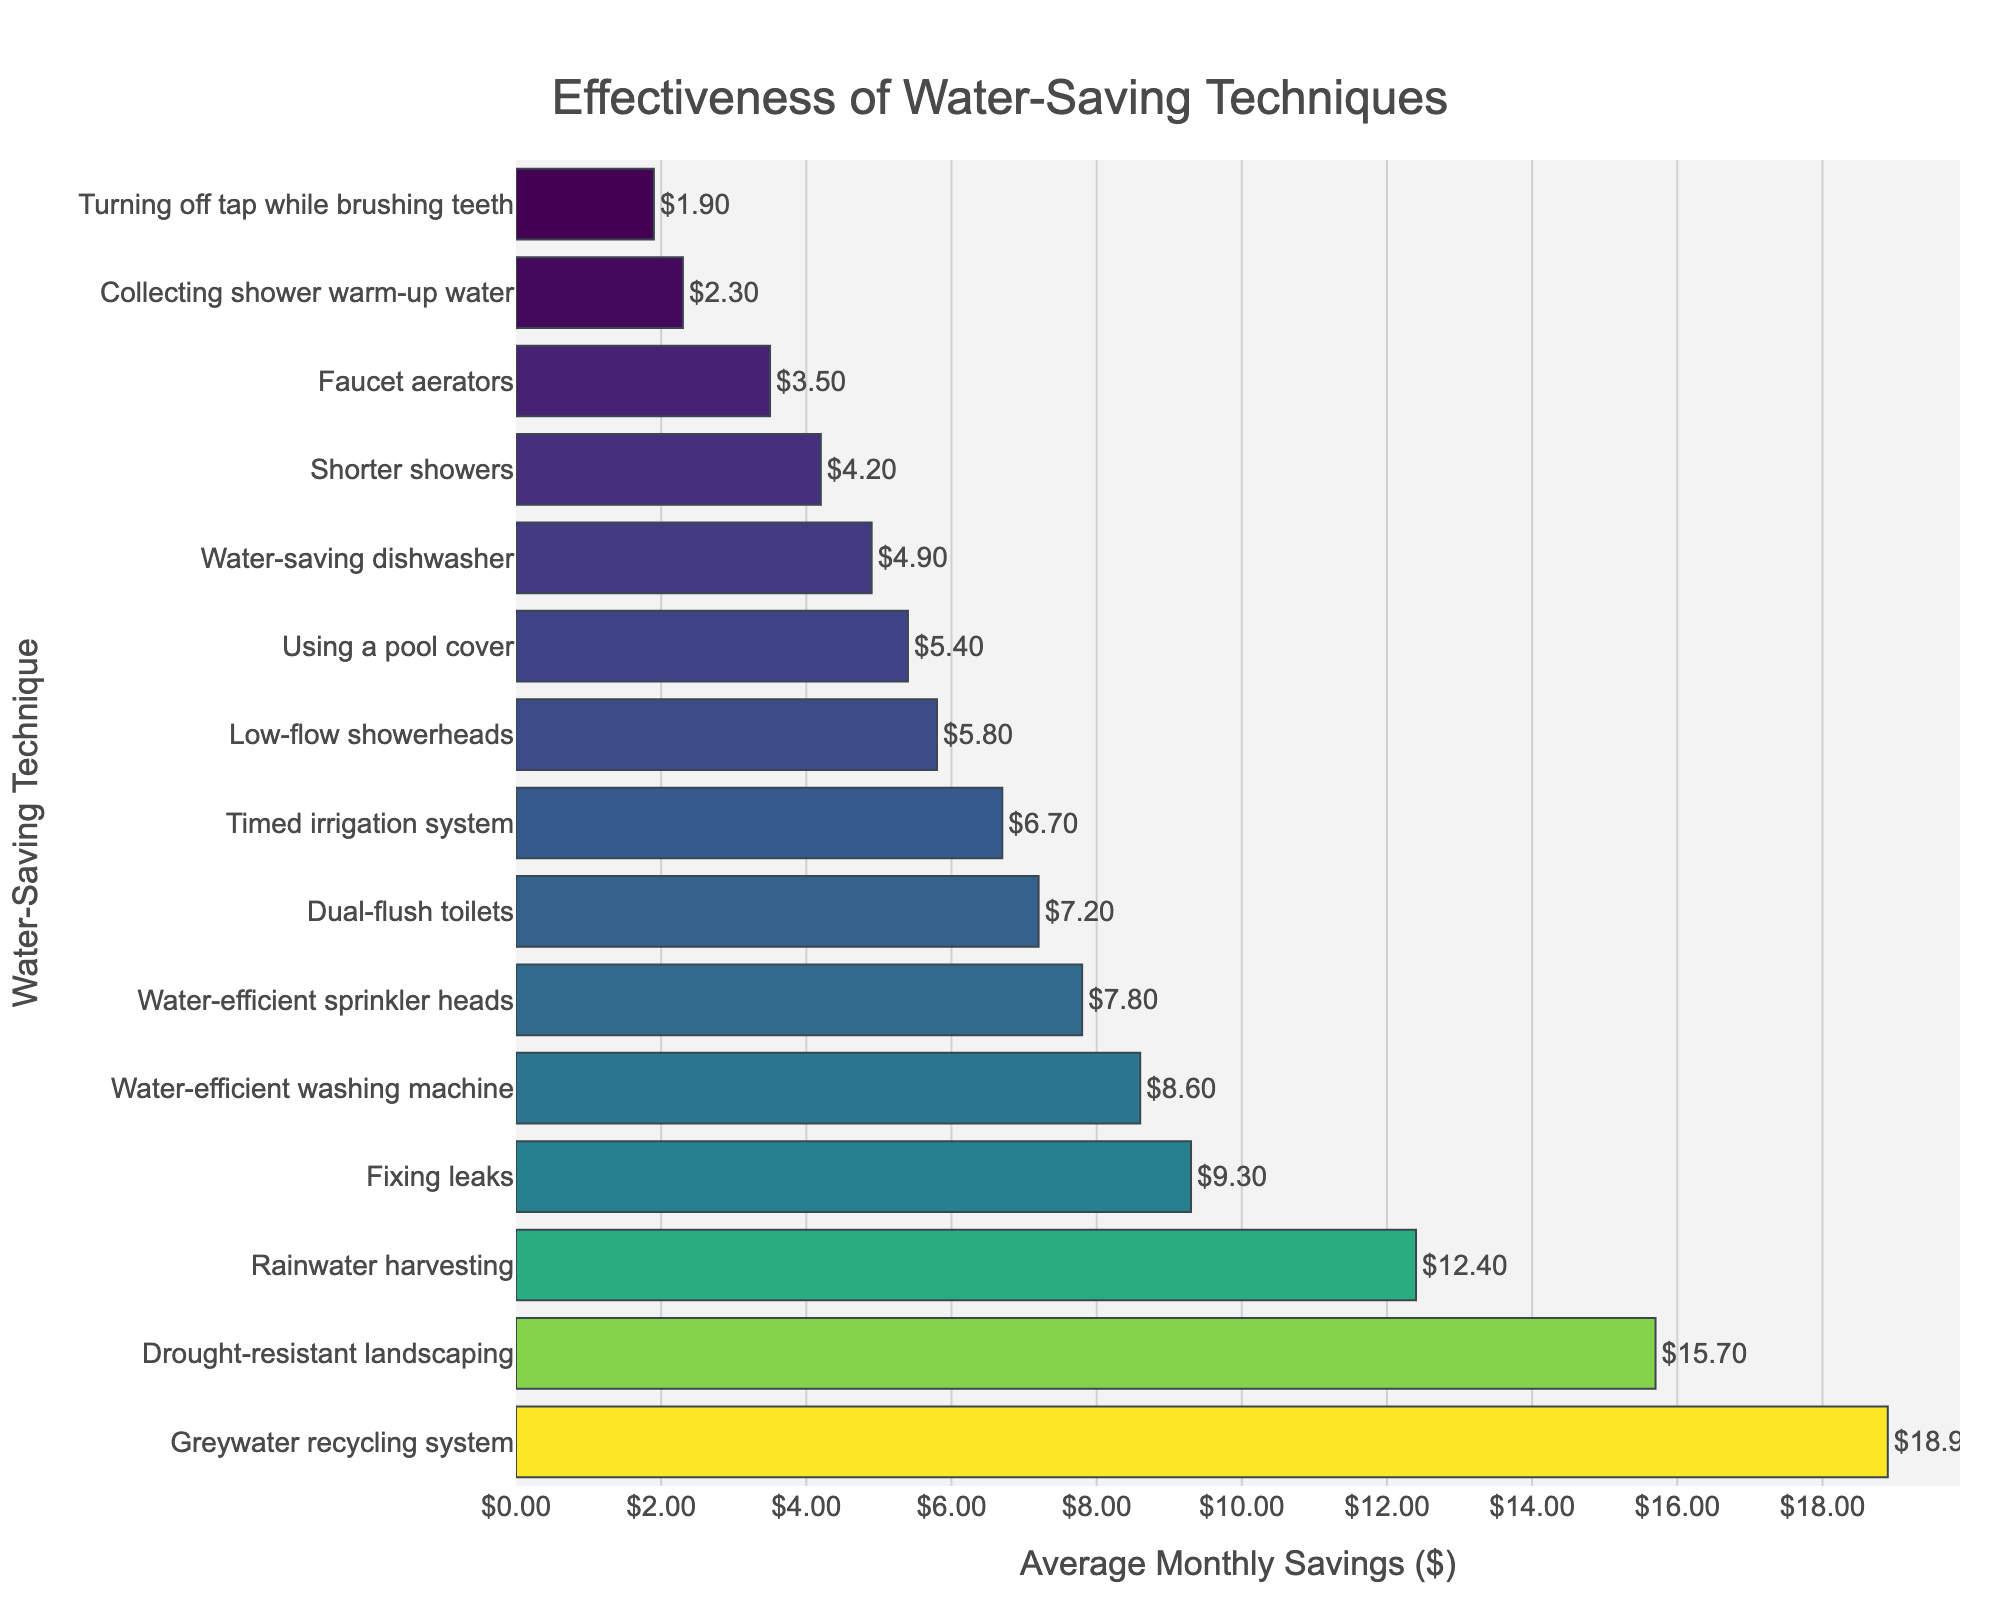Which water-saving technique results in the highest average monthly savings? Looking at the figure, identify the technique with the longest bar as it indicates the highest savings.
Answer: Greywater recycling system Which water-saving technique results in the lowest average monthly savings? Examine the figure for the shortest bar, which represents the lowest savings.
Answer: Turning off tap while brushing teeth How much more does fixing leaks save on average compared to using a pool cover? Find the bars for 'Fixing leaks' and 'Using a pool cover', then calculate the difference between their savings ($9.30 - $5.40).
Answer: $3.90 What is the total average monthly savings for using a water-efficient washing machine and a timed irrigation system? Locate the bars for 'Water-efficient washing machine' and 'Timed irrigation system', then add their savings together ($8.60 + $6.70).
Answer: $15.30 Which is more effective: dual-flush toilets or water-efficient sprinkler heads? Compare the lengths of the bars for 'Dual-flush toilets' and 'Water-efficient sprinkler heads.' The technique with the longer bar is more effective.
Answer: Water-efficient sprinkler heads How do rainwater harvesting and drought-resistant landscaping compare in terms of effectiveness? Look at the bar lengths for 'Rainwater harvesting' and 'Drought-resistant landscaping.' Identify which one is longer.
Answer: Drought-resistant landscaping What is the combined saving of the top three most effective water-saving techniques? Identify the three longest bars (Greywater recycling system, Drought-resistant landscaping, Rainwater harvesting) and sum their corresponding savings values ($18.90 + $15.70 + $12.40).
Answer: $47.00 Which water-saving technique saves approximately $5 on average per month? Look for the bar corresponding to a value around $5.
Answer: Low-flow showerheads Is the average savings from using a faucet aerator greater or less than that from collecting shower warm-up water? Compare the lengths of the bars for 'Faucet aerators' and 'Collecting shower warm-up water.' The longer bar indicates greater savings.
Answer: Greater How does the savings from shorter showers compare to fixing leaks? Identify the bars for 'Shorter showers' and 'Fixing leaks,' then observe the difference in their lengths and corresponding values.
Answer: Lower 